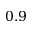Convert formula to latex. <formula><loc_0><loc_0><loc_500><loc_500>0 . 9</formula> 